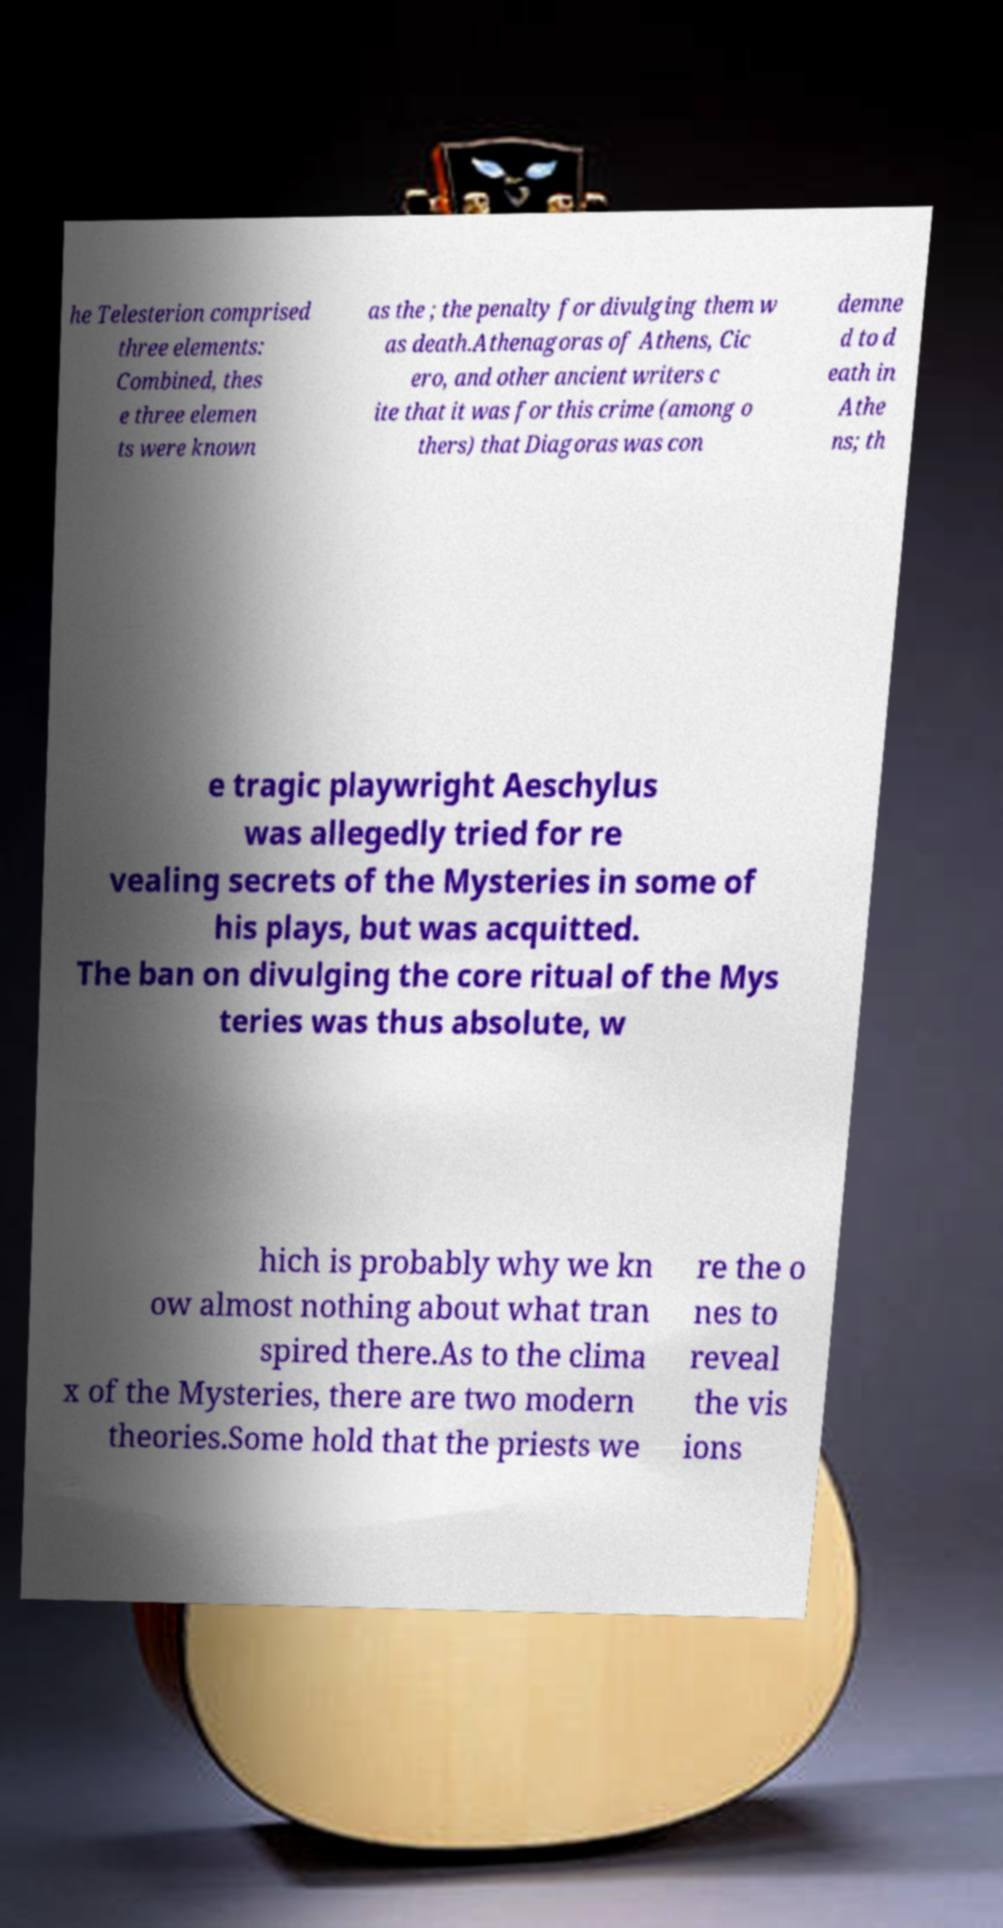Can you read and provide the text displayed in the image?This photo seems to have some interesting text. Can you extract and type it out for me? he Telesterion comprised three elements: Combined, thes e three elemen ts were known as the ; the penalty for divulging them w as death.Athenagoras of Athens, Cic ero, and other ancient writers c ite that it was for this crime (among o thers) that Diagoras was con demne d to d eath in Athe ns; th e tragic playwright Aeschylus was allegedly tried for re vealing secrets of the Mysteries in some of his plays, but was acquitted. The ban on divulging the core ritual of the Mys teries was thus absolute, w hich is probably why we kn ow almost nothing about what tran spired there.As to the clima x of the Mysteries, there are two modern theories.Some hold that the priests we re the o nes to reveal the vis ions 